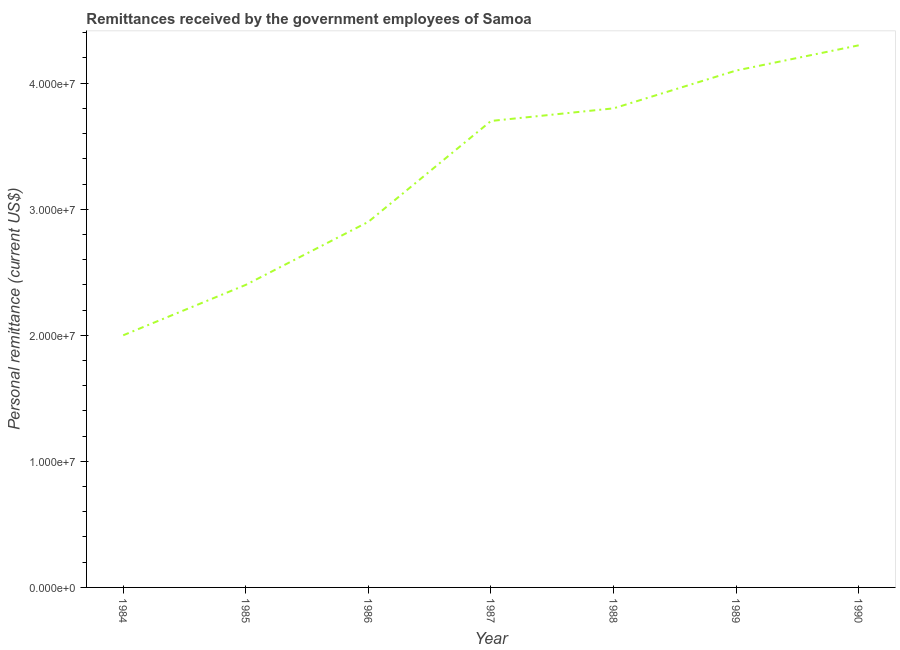What is the personal remittances in 1988?
Your answer should be very brief. 3.80e+07. Across all years, what is the maximum personal remittances?
Provide a succinct answer. 4.30e+07. What is the sum of the personal remittances?
Offer a terse response. 2.32e+08. What is the difference between the personal remittances in 1985 and 1986?
Provide a succinct answer. -5.00e+06. What is the average personal remittances per year?
Provide a short and direct response. 3.31e+07. What is the median personal remittances?
Make the answer very short. 3.70e+07. What is the ratio of the personal remittances in 1985 to that in 1987?
Offer a very short reply. 0.65. Is the personal remittances in 1985 less than that in 1989?
Provide a short and direct response. Yes. What is the difference between the highest and the second highest personal remittances?
Give a very brief answer. 2.00e+06. Is the sum of the personal remittances in 1985 and 1988 greater than the maximum personal remittances across all years?
Provide a short and direct response. Yes. What is the difference between the highest and the lowest personal remittances?
Provide a short and direct response. 2.30e+07. In how many years, is the personal remittances greater than the average personal remittances taken over all years?
Your answer should be very brief. 4. How many lines are there?
Your answer should be compact. 1. How many years are there in the graph?
Offer a very short reply. 7. Are the values on the major ticks of Y-axis written in scientific E-notation?
Give a very brief answer. Yes. Does the graph contain grids?
Provide a succinct answer. No. What is the title of the graph?
Your response must be concise. Remittances received by the government employees of Samoa. What is the label or title of the Y-axis?
Provide a short and direct response. Personal remittance (current US$). What is the Personal remittance (current US$) of 1984?
Offer a terse response. 2.00e+07. What is the Personal remittance (current US$) of 1985?
Ensure brevity in your answer.  2.40e+07. What is the Personal remittance (current US$) of 1986?
Provide a succinct answer. 2.90e+07. What is the Personal remittance (current US$) in 1987?
Your response must be concise. 3.70e+07. What is the Personal remittance (current US$) of 1988?
Ensure brevity in your answer.  3.80e+07. What is the Personal remittance (current US$) of 1989?
Give a very brief answer. 4.10e+07. What is the Personal remittance (current US$) of 1990?
Provide a short and direct response. 4.30e+07. What is the difference between the Personal remittance (current US$) in 1984 and 1986?
Your answer should be very brief. -9.00e+06. What is the difference between the Personal remittance (current US$) in 1984 and 1987?
Your response must be concise. -1.70e+07. What is the difference between the Personal remittance (current US$) in 1984 and 1988?
Your response must be concise. -1.80e+07. What is the difference between the Personal remittance (current US$) in 1984 and 1989?
Provide a succinct answer. -2.10e+07. What is the difference between the Personal remittance (current US$) in 1984 and 1990?
Offer a terse response. -2.30e+07. What is the difference between the Personal remittance (current US$) in 1985 and 1986?
Make the answer very short. -5.00e+06. What is the difference between the Personal remittance (current US$) in 1985 and 1987?
Offer a very short reply. -1.30e+07. What is the difference between the Personal remittance (current US$) in 1985 and 1988?
Offer a very short reply. -1.40e+07. What is the difference between the Personal remittance (current US$) in 1985 and 1989?
Provide a succinct answer. -1.70e+07. What is the difference between the Personal remittance (current US$) in 1985 and 1990?
Give a very brief answer. -1.90e+07. What is the difference between the Personal remittance (current US$) in 1986 and 1987?
Make the answer very short. -8.00e+06. What is the difference between the Personal remittance (current US$) in 1986 and 1988?
Your answer should be very brief. -9.00e+06. What is the difference between the Personal remittance (current US$) in 1986 and 1989?
Keep it short and to the point. -1.20e+07. What is the difference between the Personal remittance (current US$) in 1986 and 1990?
Your answer should be compact. -1.40e+07. What is the difference between the Personal remittance (current US$) in 1987 and 1989?
Give a very brief answer. -4.00e+06. What is the difference between the Personal remittance (current US$) in 1987 and 1990?
Make the answer very short. -6.00e+06. What is the difference between the Personal remittance (current US$) in 1988 and 1990?
Your answer should be very brief. -5.00e+06. What is the difference between the Personal remittance (current US$) in 1989 and 1990?
Ensure brevity in your answer.  -2.00e+06. What is the ratio of the Personal remittance (current US$) in 1984 to that in 1985?
Keep it short and to the point. 0.83. What is the ratio of the Personal remittance (current US$) in 1984 to that in 1986?
Make the answer very short. 0.69. What is the ratio of the Personal remittance (current US$) in 1984 to that in 1987?
Ensure brevity in your answer.  0.54. What is the ratio of the Personal remittance (current US$) in 1984 to that in 1988?
Ensure brevity in your answer.  0.53. What is the ratio of the Personal remittance (current US$) in 1984 to that in 1989?
Provide a succinct answer. 0.49. What is the ratio of the Personal remittance (current US$) in 1984 to that in 1990?
Your answer should be very brief. 0.47. What is the ratio of the Personal remittance (current US$) in 1985 to that in 1986?
Your answer should be compact. 0.83. What is the ratio of the Personal remittance (current US$) in 1985 to that in 1987?
Offer a terse response. 0.65. What is the ratio of the Personal remittance (current US$) in 1985 to that in 1988?
Provide a succinct answer. 0.63. What is the ratio of the Personal remittance (current US$) in 1985 to that in 1989?
Your answer should be compact. 0.58. What is the ratio of the Personal remittance (current US$) in 1985 to that in 1990?
Your answer should be very brief. 0.56. What is the ratio of the Personal remittance (current US$) in 1986 to that in 1987?
Your answer should be compact. 0.78. What is the ratio of the Personal remittance (current US$) in 1986 to that in 1988?
Your answer should be compact. 0.76. What is the ratio of the Personal remittance (current US$) in 1986 to that in 1989?
Give a very brief answer. 0.71. What is the ratio of the Personal remittance (current US$) in 1986 to that in 1990?
Your answer should be compact. 0.67. What is the ratio of the Personal remittance (current US$) in 1987 to that in 1988?
Keep it short and to the point. 0.97. What is the ratio of the Personal remittance (current US$) in 1987 to that in 1989?
Offer a terse response. 0.9. What is the ratio of the Personal remittance (current US$) in 1987 to that in 1990?
Provide a short and direct response. 0.86. What is the ratio of the Personal remittance (current US$) in 1988 to that in 1989?
Offer a very short reply. 0.93. What is the ratio of the Personal remittance (current US$) in 1988 to that in 1990?
Keep it short and to the point. 0.88. What is the ratio of the Personal remittance (current US$) in 1989 to that in 1990?
Offer a terse response. 0.95. 